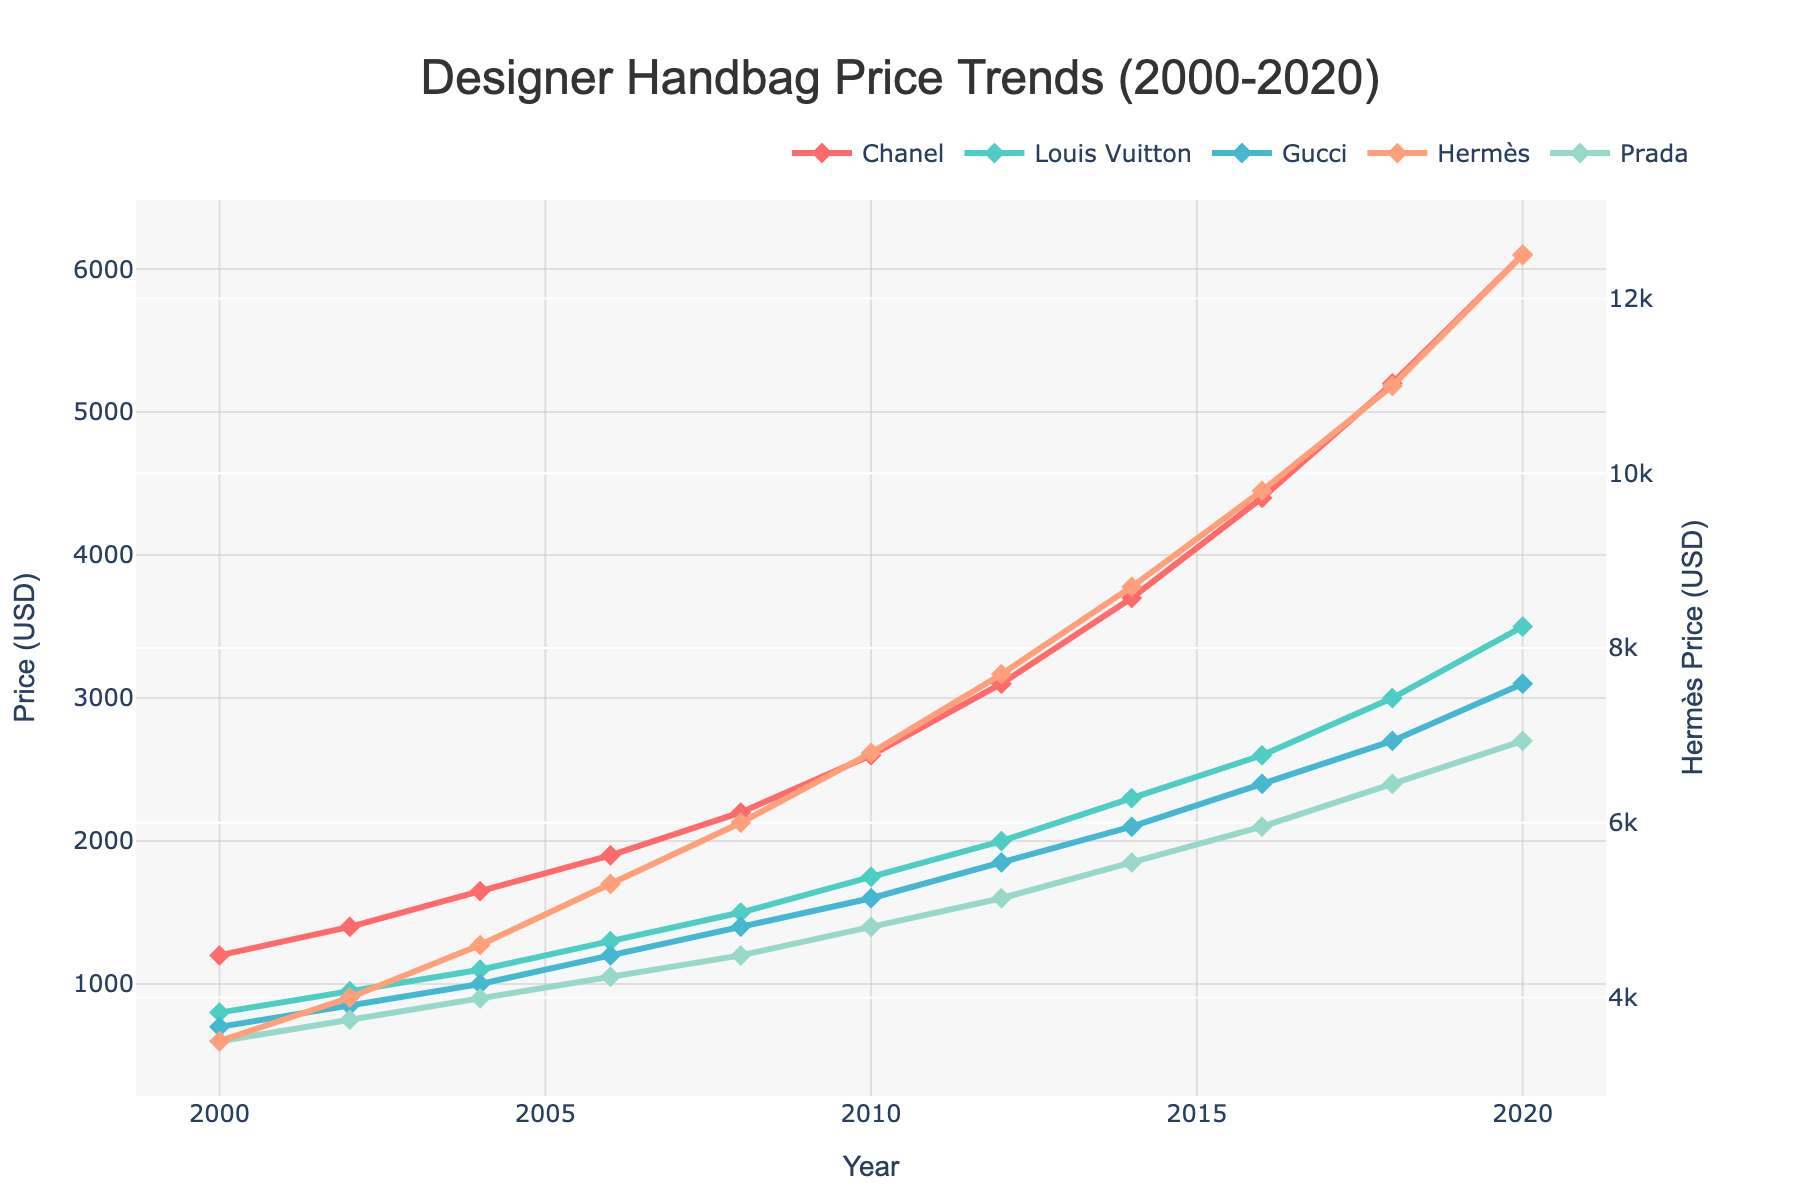What is the trend in the price of Chanel handbags from 2000 to 2020? The price of Chanel handbags shows a consistent upward trend over the years. It starts at $1,200 in 2000 and increases to $6,100 by 2020. The increments become more significant over time.
Answer: Upward Between Gucci and Louis Vuitton, which brand had a higher average handbag price from 2000 to 2020? To determine the average, sum up the prices for each brand from 2000 to 2020 and divide by the number of years (11). Summing up Gucci's prices: 700 + 850 + 1000 + 1200 + 1400 + 1600 + 1850 + 2100 + 2400 + 2700 + 3100 = 19900. Dividing by 11 gives: 19900 / 11 ≈ 1810. Summing up Louis Vuitton's prices: 800 + 950 + 1100 + 1300 + 1500 + 1750 + 2000 + 2300 + 2600 + 3000 + 3500 = 20800. Dividing by 11 gives: 20800 / 11 ≈ 1891.
Answer: Louis Vuitton Which brand showed the steepest increase in handbag prices between 2014 and 2016? Compare the price change for each brand between 2014 and 2016. Chanel: 4400 - 3700 = 700. Louis Vuitton: 2600 - 2300 = 300. Gucci: 2400 - 2100 = 300. Hermès: 9800 - 8700 = 1100. Prada: 2100 - 1850 = 250. Hermès shows the steepest increase.
Answer: Hermès What were the prices of Hermès handbags in 2004 and 2008, and how much did they increase by? Check the prices in the given years. In 2004, Hermès was $4,600, and in 2008, it was $6,000. The increase is 6000 - 4600 = 1400.
Answer: 4600 and 6000, increased by 1400 Considering visual attributes, which brand is represented by the red line and what is its trend over the years? The red line represents Chanel. The trend shows a significant and steady increase from $1,200 in 2000 to $6,100 in 2020.
Answer: Chanel, increasing Which year did Prada handbags first cross the $1000 mark? Locate the point when Prada's price exceeds $1000 for the first time. In 2006, the price is exactly $1050, crossing the $1000 threshold.
Answer: 2006 By how much did Louis Vuitton handbag prices increase from 2000 to 2020? The price in 2000 was $800, and by 2020, it was $3500. The increase is 3500 - 800 = 2700.
Answer: 2700 Which brand had the highest price in 2020 and what was the amount? The brand with the highest 2020 price is Hermès at $12,500.
Answer: Hermès, 12500 